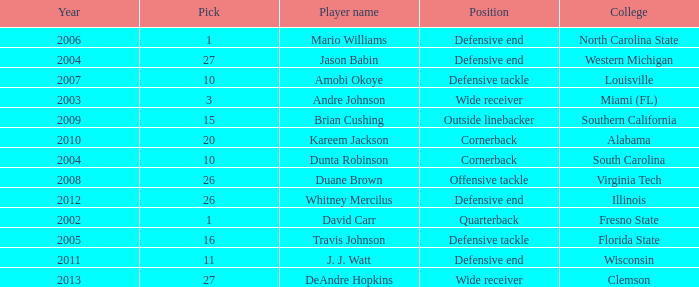What pick was mario williams before 2006? None. 